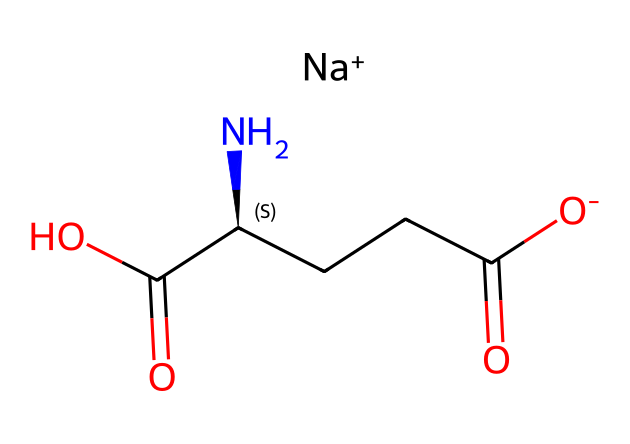What is the full name of the chemical represented by this SMILES? The SMILES notation indicates the presence of sodium (Na), glutamate groups (as seen in the carboxylic acid function), and suggests that the full name is monosodium glutamate.
Answer: monosodium glutamate How many carbon atoms are present in this chemical? By examining the SMILES representation, we can see a total of five carbon atoms present in the structure.
Answer: five What is the total number of nitrogen atoms in this chemical? Looking at the SMILES, there is only one nitrogen atom present as indicated in the amino acid part of the structure.
Answer: one What functional groups are present in this chemical? The chemical consists of carboxylic acid and an amine group, as evidenced by the COOH and NH2 groups in the structure.
Answer: carboxylic acid and amine What is the sodium ion representation in this chemical? The sodium ion is represented as [Na+] in the SMILES, indicating it is present as a cation in the overall charge balance of the molecule.
Answer: [Na+] How does the presence of the sodium ion affect the flavor of this chemical? The sodium ion enhances the taste as it works synergistically with glutamate to amplify umami flavor, making the food more savory.
Answer: enhances umami flavor What type of additive is monosodium glutamate classified as? Monosodium glutamate is classified as a flavor enhancer due to its ability to improve the taste profile of food products.
Answer: flavor enhancer 